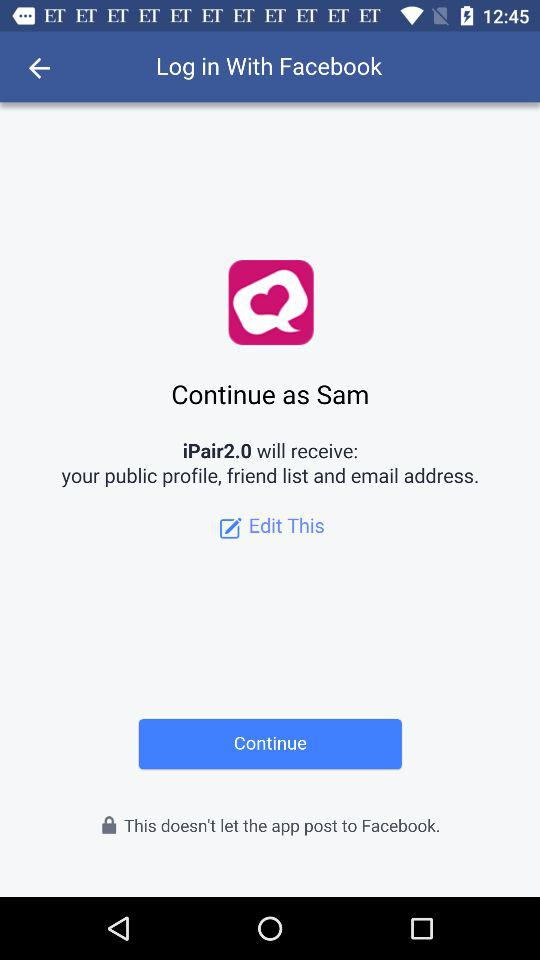What application is asking for permission? The application "iPair2.0" is asking for permission. 